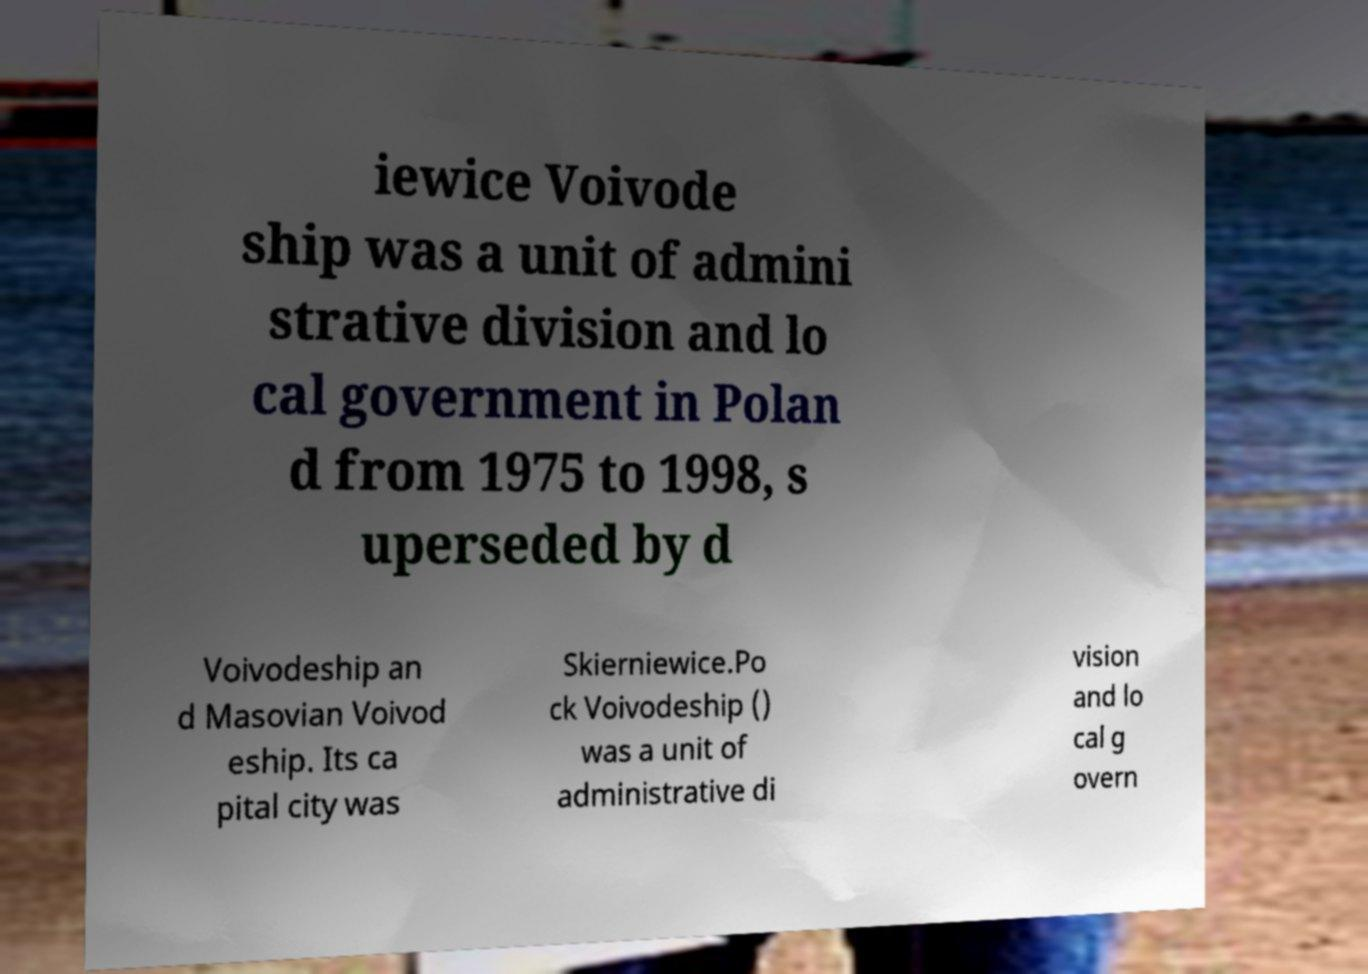What messages or text are displayed in this image? I need them in a readable, typed format. iewice Voivode ship was a unit of admini strative division and lo cal government in Polan d from 1975 to 1998, s uperseded by d Voivodeship an d Masovian Voivod eship. Its ca pital city was Skierniewice.Po ck Voivodeship () was a unit of administrative di vision and lo cal g overn 